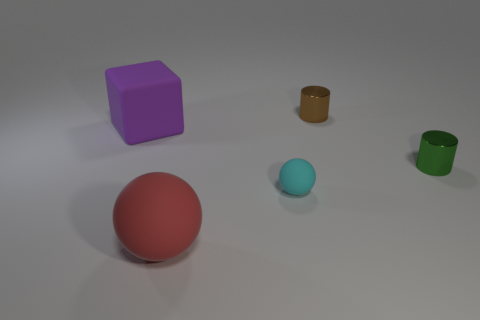There is a big cube that is the same material as the small ball; what color is it?
Give a very brief answer. Purple. Are there any small things in front of the shiny cylinder that is on the right side of the small shiny cylinder that is behind the purple block?
Give a very brief answer. Yes. What is the shape of the tiny green object?
Provide a succinct answer. Cylinder. Is the number of purple cubes that are on the left side of the large red rubber sphere less than the number of cubes?
Offer a very short reply. No. Are there any large things that have the same shape as the tiny matte object?
Ensure brevity in your answer.  Yes. There is a red matte object that is the same size as the purple matte cube; what shape is it?
Provide a short and direct response. Sphere. What number of things are either small brown shiny objects or blue matte cylinders?
Offer a very short reply. 1. Is there a red matte sphere?
Your answer should be compact. Yes. Are there fewer small purple metal cylinders than big blocks?
Make the answer very short. Yes. Are there any matte things that have the same size as the purple block?
Your response must be concise. Yes. 